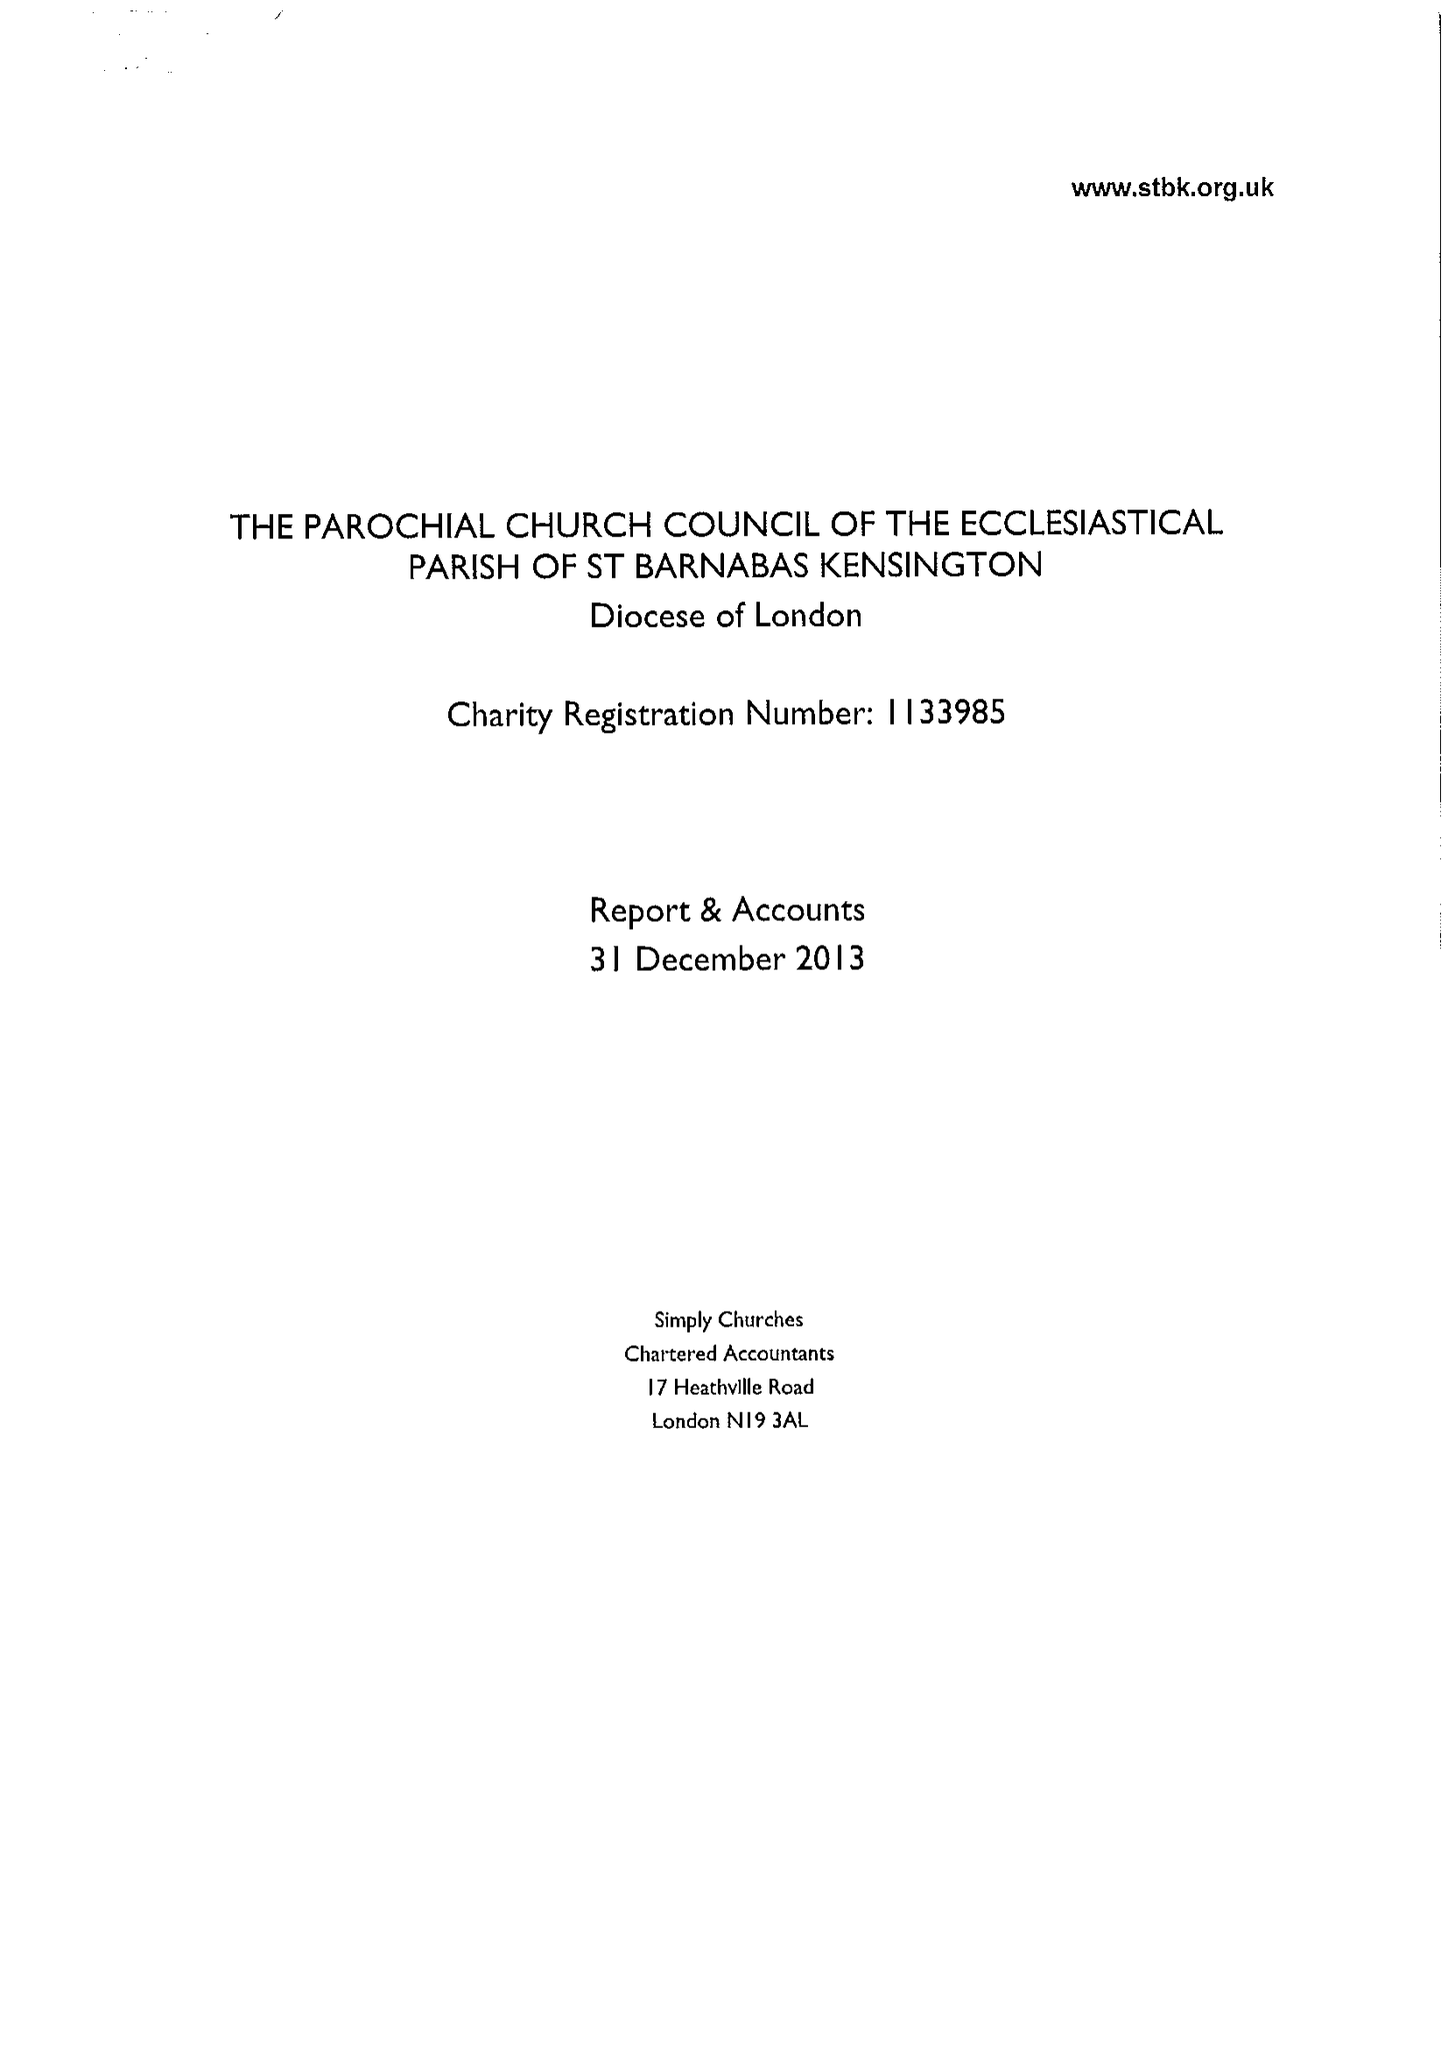What is the value for the address__post_town?
Answer the question using a single word or phrase. LONDON 